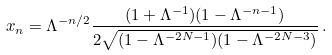Convert formula to latex. <formula><loc_0><loc_0><loc_500><loc_500>x _ { n } = \Lambda ^ { - n / 2 } \frac { ( 1 + \Lambda ^ { - 1 } ) ( 1 - \Lambda ^ { - n - 1 } ) } { 2 \sqrt { ( 1 - \Lambda ^ { - 2 N - 1 } ) ( 1 - \Lambda ^ { - 2 N - 3 } ) } } \, .</formula> 